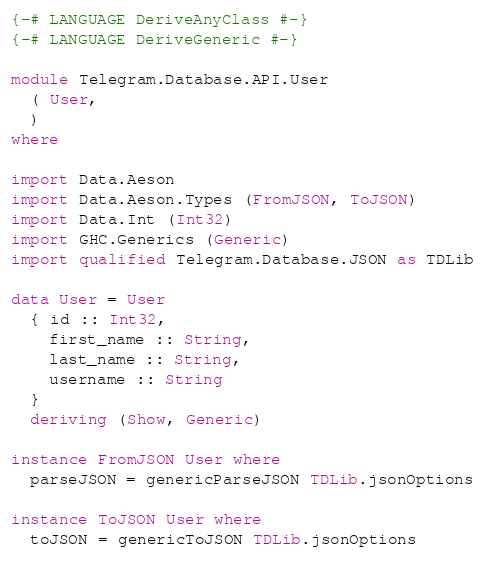<code> <loc_0><loc_0><loc_500><loc_500><_Haskell_>{-# LANGUAGE DeriveAnyClass #-}
{-# LANGUAGE DeriveGeneric #-}

module Telegram.Database.API.User
  ( User,
  )
where

import Data.Aeson
import Data.Aeson.Types (FromJSON, ToJSON)
import Data.Int (Int32)
import GHC.Generics (Generic)
import qualified Telegram.Database.JSON as TDLib

data User = User
  { id :: Int32,
    first_name :: String,
    last_name :: String,
    username :: String
  }
  deriving (Show, Generic)

instance FromJSON User where
  parseJSON = genericParseJSON TDLib.jsonOptions

instance ToJSON User where
  toJSON = genericToJSON TDLib.jsonOptions
</code> 